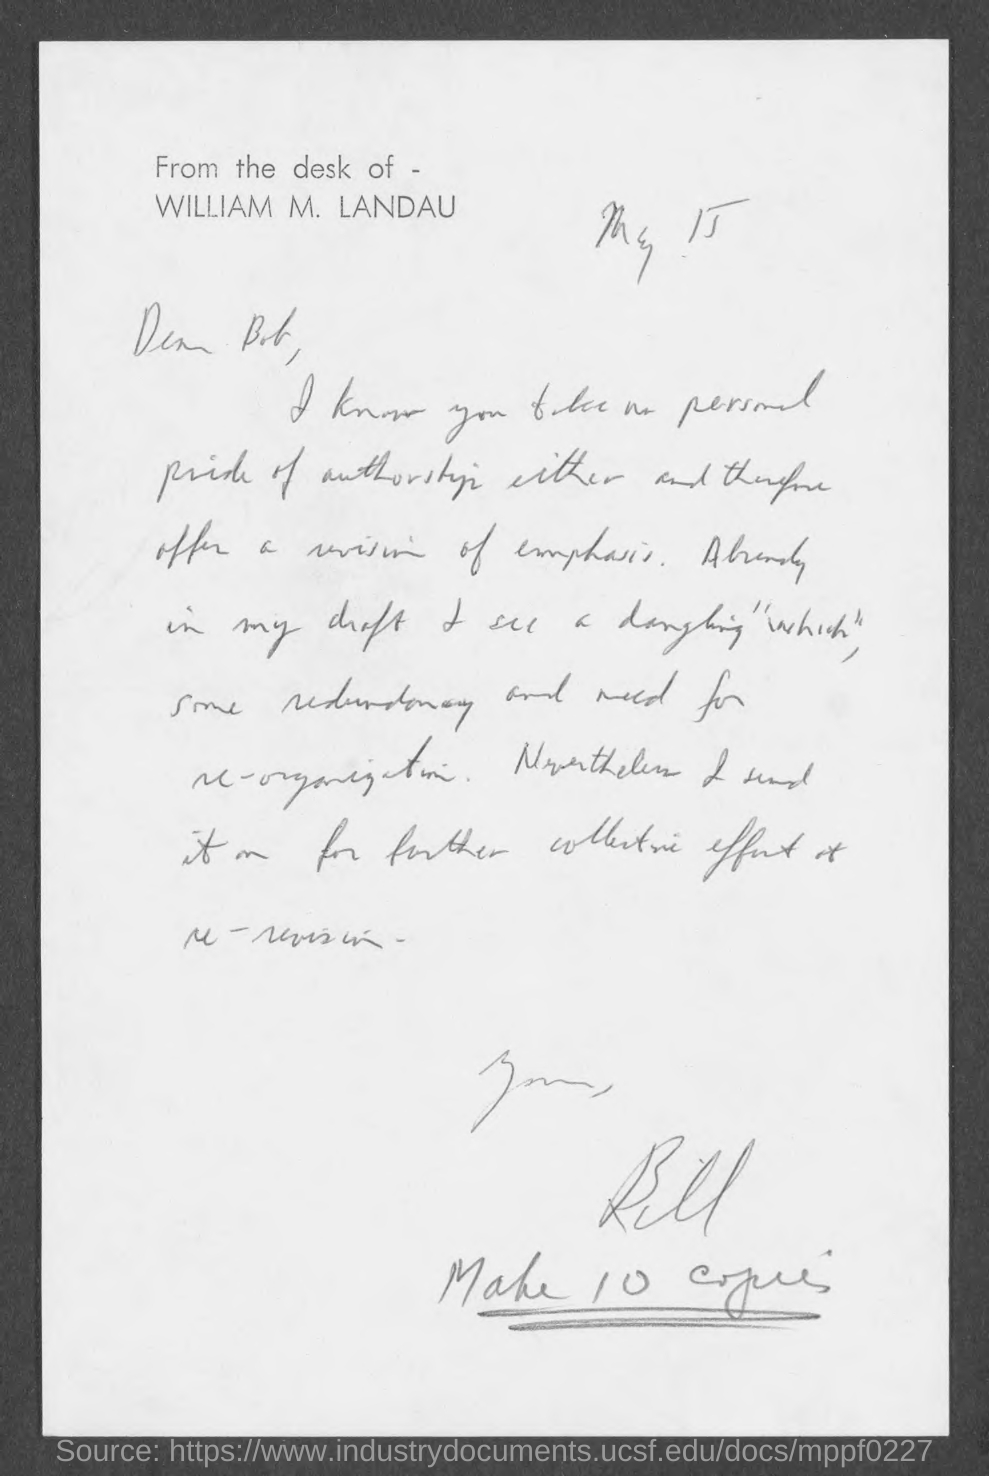Give some essential details in this illustration. The subject is "this letter" and the predicate is "is written to BOB...". 